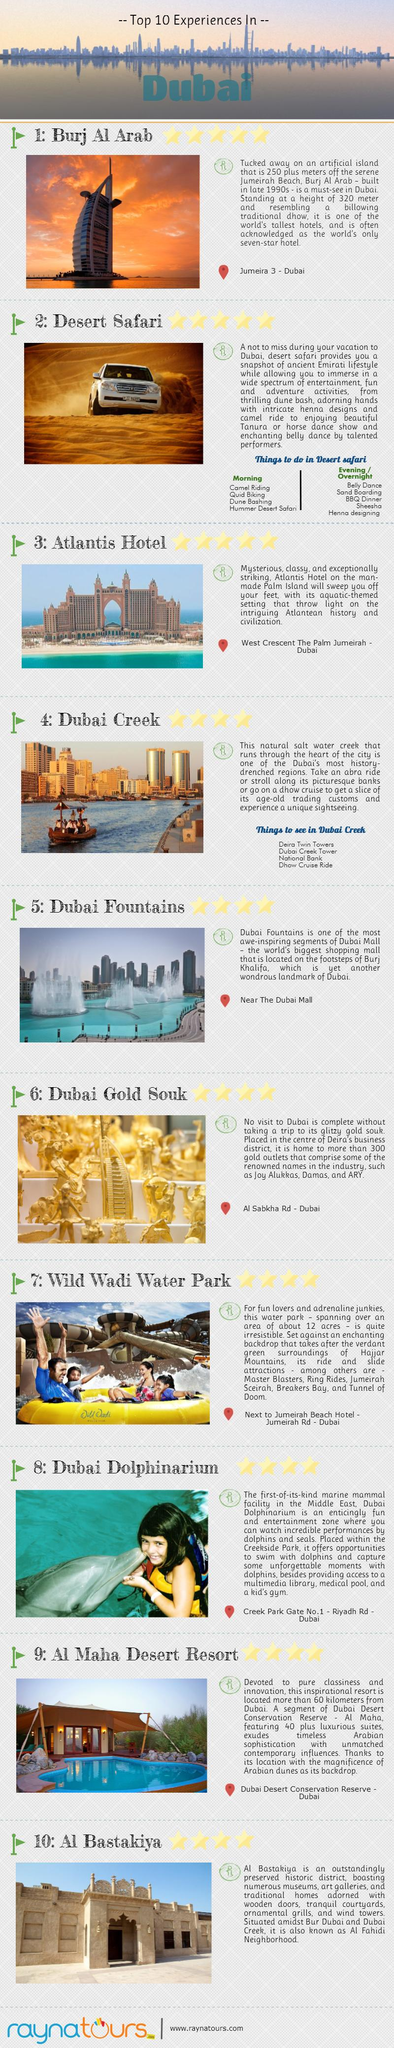List a handful of essential elements in this visual. The Dubai Gold Souk is located on Al Sabkha Road in Dubai. A Dhow Cruise Ride is available in Dubai Creek, providing a unique and unforgettable experience for visitors. The Atlantis Hotel is situated on the Palm Island, a man-made island located in Dubai. The Burj Al Arab is located in Jumeira 3, Dubai. Al Bastakiya District, also known as Al Fahidi Neighborhood, is a historic district in Dubai that is known for its traditional architecture and cultural significance. 